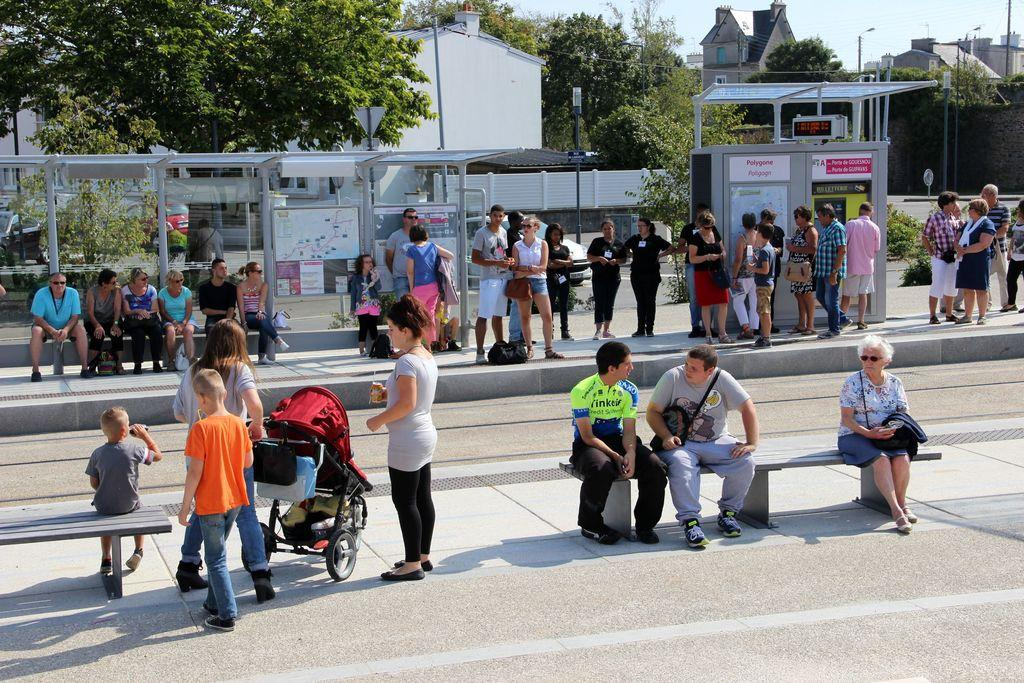How many people are present in the image? There are many people in the image. What are the people doing in the image? The people are waiting on a platform. Can you describe the positions of some of the people? Some people are sitting on benches, while others are standing. What type of bells can be heard ringing in the image? There are no bells present in the image, and therefore no sound can be heard. How much waste is visible in the image? There is no mention of waste in the image, so it cannot be determined from the image. 